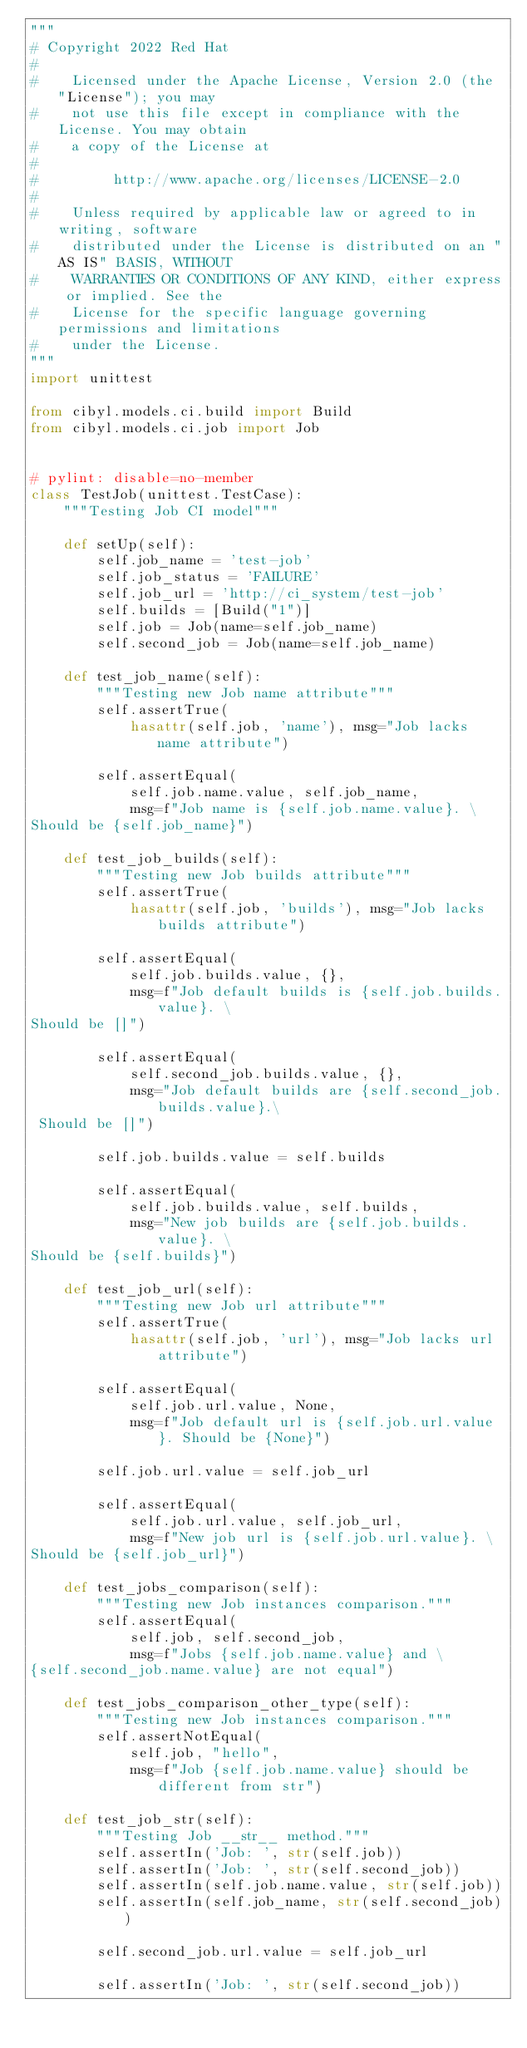<code> <loc_0><loc_0><loc_500><loc_500><_Python_>"""
# Copyright 2022 Red Hat
#
#    Licensed under the Apache License, Version 2.0 (the "License"); you may
#    not use this file except in compliance with the License. You may obtain
#    a copy of the License at
#
#         http://www.apache.org/licenses/LICENSE-2.0
#
#    Unless required by applicable law or agreed to in writing, software
#    distributed under the License is distributed on an "AS IS" BASIS, WITHOUT
#    WARRANTIES OR CONDITIONS OF ANY KIND, either express or implied. See the
#    License for the specific language governing permissions and limitations
#    under the License.
"""
import unittest

from cibyl.models.ci.build import Build
from cibyl.models.ci.job import Job


# pylint: disable=no-member
class TestJob(unittest.TestCase):
    """Testing Job CI model"""

    def setUp(self):
        self.job_name = 'test-job'
        self.job_status = 'FAILURE'
        self.job_url = 'http://ci_system/test-job'
        self.builds = [Build("1")]
        self.job = Job(name=self.job_name)
        self.second_job = Job(name=self.job_name)

    def test_job_name(self):
        """Testing new Job name attribute"""
        self.assertTrue(
            hasattr(self.job, 'name'), msg="Job lacks name attribute")

        self.assertEqual(
            self.job.name.value, self.job_name,
            msg=f"Job name is {self.job.name.value}. \
Should be {self.job_name}")

    def test_job_builds(self):
        """Testing new Job builds attribute"""
        self.assertTrue(
            hasattr(self.job, 'builds'), msg="Job lacks builds attribute")

        self.assertEqual(
            self.job.builds.value, {},
            msg=f"Job default builds is {self.job.builds.value}. \
Should be []")

        self.assertEqual(
            self.second_job.builds.value, {},
            msg="Job default builds are {self.second_job.builds.value}.\
 Should be []")

        self.job.builds.value = self.builds

        self.assertEqual(
            self.job.builds.value, self.builds,
            msg="New job builds are {self.job.builds.value}. \
Should be {self.builds}")

    def test_job_url(self):
        """Testing new Job url attribute"""
        self.assertTrue(
            hasattr(self.job, 'url'), msg="Job lacks url attribute")

        self.assertEqual(
            self.job.url.value, None,
            msg=f"Job default url is {self.job.url.value}. Should be {None}")

        self.job.url.value = self.job_url

        self.assertEqual(
            self.job.url.value, self.job_url,
            msg=f"New job url is {self.job.url.value}. \
Should be {self.job_url}")

    def test_jobs_comparison(self):
        """Testing new Job instances comparison."""
        self.assertEqual(
            self.job, self.second_job,
            msg=f"Jobs {self.job.name.value} and \
{self.second_job.name.value} are not equal")

    def test_jobs_comparison_other_type(self):
        """Testing new Job instances comparison."""
        self.assertNotEqual(
            self.job, "hello",
            msg=f"Job {self.job.name.value} should be different from str")

    def test_job_str(self):
        """Testing Job __str__ method."""
        self.assertIn('Job: ', str(self.job))
        self.assertIn('Job: ', str(self.second_job))
        self.assertIn(self.job.name.value, str(self.job))
        self.assertIn(self.job_name, str(self.second_job))

        self.second_job.url.value = self.job_url

        self.assertIn('Job: ', str(self.second_job))</code> 